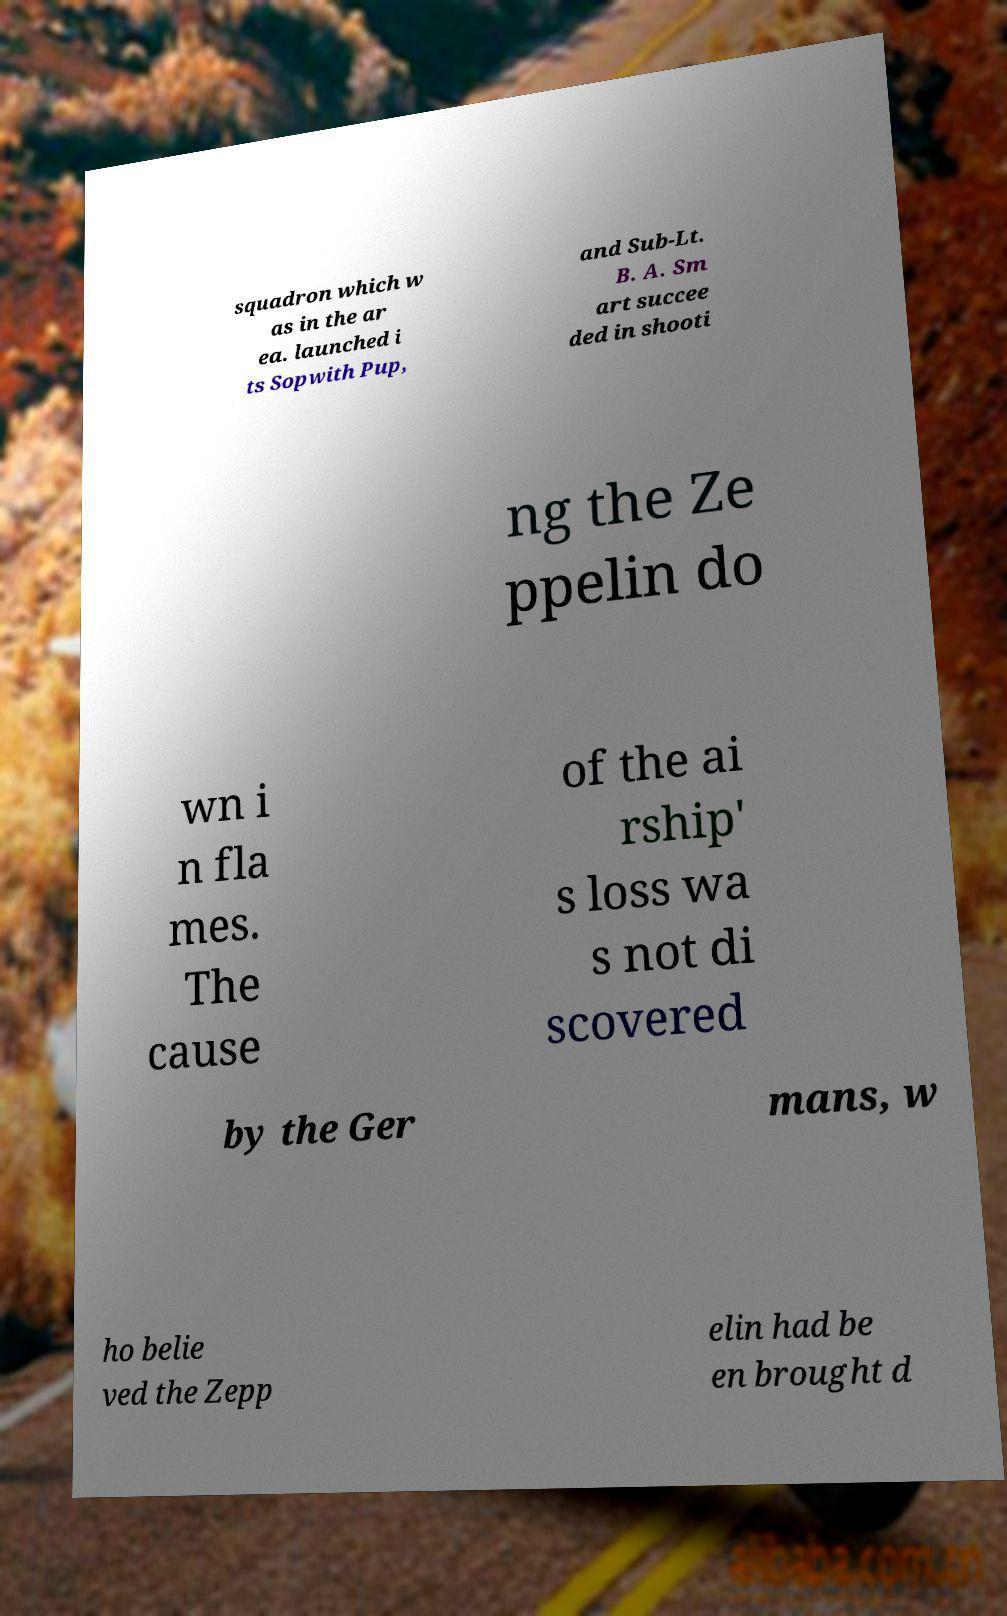Can you accurately transcribe the text from the provided image for me? squadron which w as in the ar ea. launched i ts Sopwith Pup, and Sub-Lt. B. A. Sm art succee ded in shooti ng the Ze ppelin do wn i n fla mes. The cause of the ai rship' s loss wa s not di scovered by the Ger mans, w ho belie ved the Zepp elin had be en brought d 